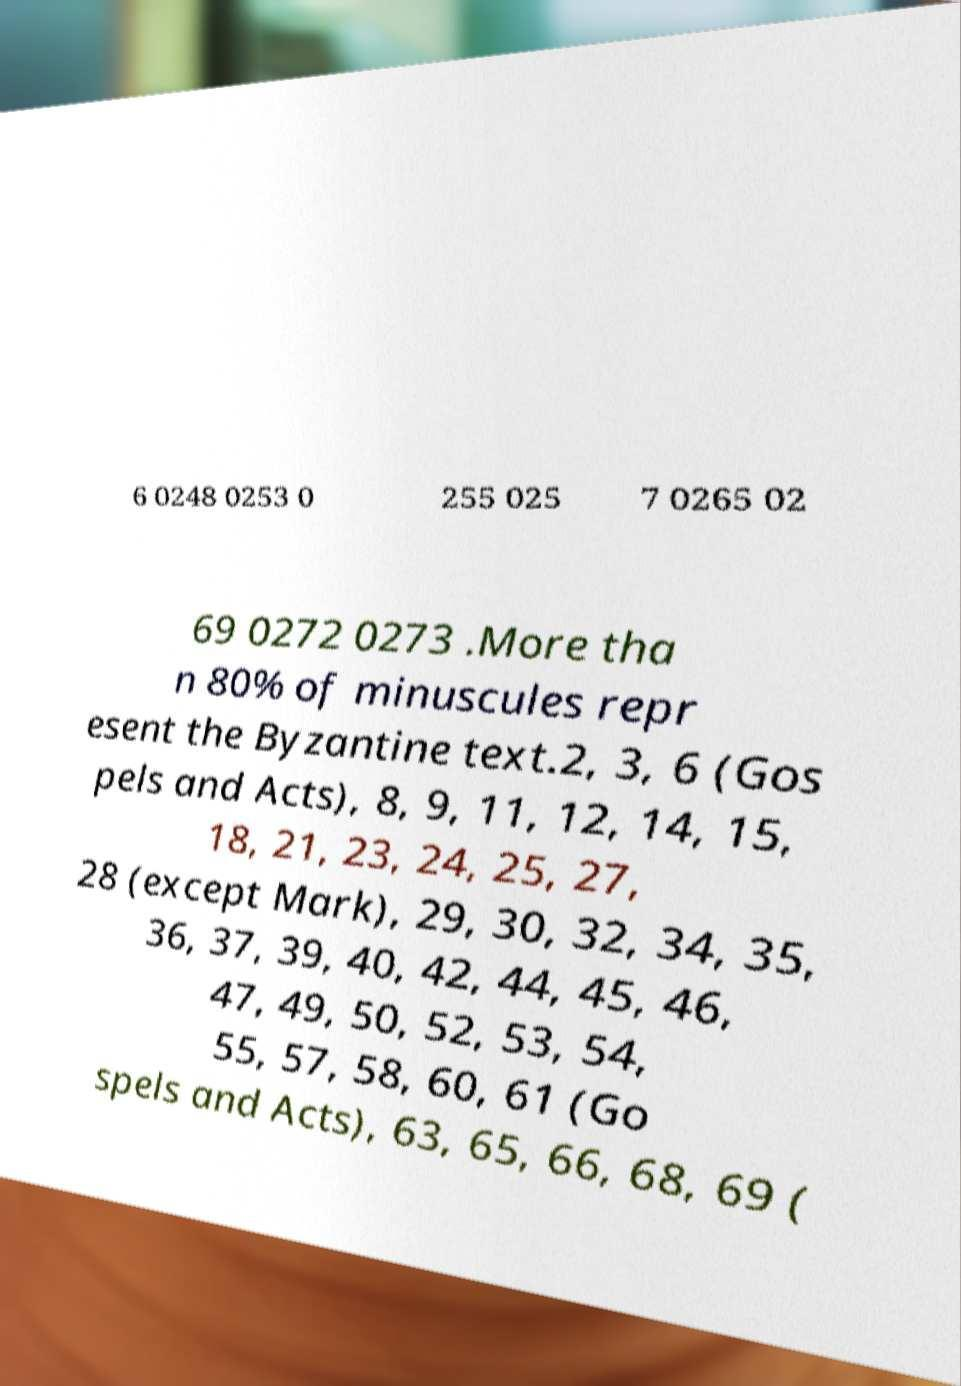There's text embedded in this image that I need extracted. Can you transcribe it verbatim? 6 0248 0253 0 255 025 7 0265 02 69 0272 0273 .More tha n 80% of minuscules repr esent the Byzantine text.2, 3, 6 (Gos pels and Acts), 8, 9, 11, 12, 14, 15, 18, 21, 23, 24, 25, 27, 28 (except Mark), 29, 30, 32, 34, 35, 36, 37, 39, 40, 42, 44, 45, 46, 47, 49, 50, 52, 53, 54, 55, 57, 58, 60, 61 (Go spels and Acts), 63, 65, 66, 68, 69 ( 